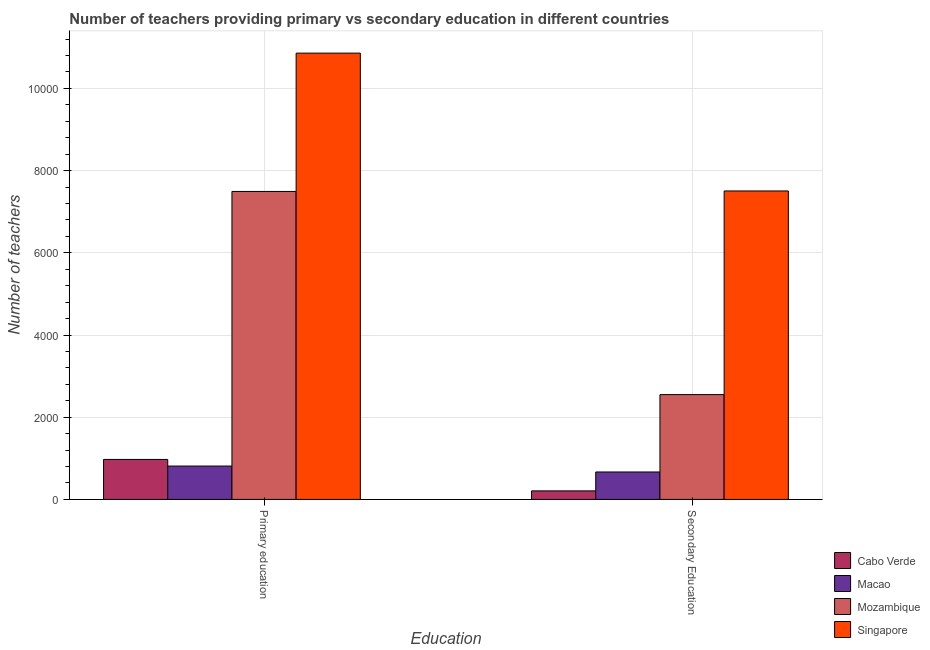How many different coloured bars are there?
Your answer should be compact. 4. Are the number of bars on each tick of the X-axis equal?
Provide a succinct answer. Yes. What is the label of the 2nd group of bars from the left?
Make the answer very short. Secondary Education. What is the number of primary teachers in Mozambique?
Your answer should be compact. 7493. Across all countries, what is the maximum number of secondary teachers?
Your answer should be compact. 7505. Across all countries, what is the minimum number of primary teachers?
Offer a very short reply. 812. In which country was the number of secondary teachers maximum?
Give a very brief answer. Singapore. In which country was the number of secondary teachers minimum?
Provide a short and direct response. Cabo Verde. What is the total number of primary teachers in the graph?
Your answer should be compact. 2.01e+04. What is the difference between the number of primary teachers in Cabo Verde and that in Macao?
Provide a short and direct response. 161. What is the difference between the number of secondary teachers in Cabo Verde and the number of primary teachers in Macao?
Your response must be concise. -604. What is the average number of primary teachers per country?
Your answer should be very brief. 5034. What is the difference between the number of secondary teachers and number of primary teachers in Macao?
Provide a succinct answer. -144. In how many countries, is the number of primary teachers greater than 9200 ?
Provide a succinct answer. 1. What is the ratio of the number of primary teachers in Singapore to that in Cabo Verde?
Provide a succinct answer. 11.16. In how many countries, is the number of primary teachers greater than the average number of primary teachers taken over all countries?
Your answer should be very brief. 2. What does the 2nd bar from the left in Primary education represents?
Your answer should be compact. Macao. What does the 4th bar from the right in Secondary Education represents?
Ensure brevity in your answer.  Cabo Verde. Are all the bars in the graph horizontal?
Provide a short and direct response. No. Does the graph contain any zero values?
Your response must be concise. No. Where does the legend appear in the graph?
Provide a short and direct response. Bottom right. How many legend labels are there?
Make the answer very short. 4. How are the legend labels stacked?
Give a very brief answer. Vertical. What is the title of the graph?
Give a very brief answer. Number of teachers providing primary vs secondary education in different countries. Does "Madagascar" appear as one of the legend labels in the graph?
Offer a very short reply. No. What is the label or title of the X-axis?
Your response must be concise. Education. What is the label or title of the Y-axis?
Keep it short and to the point. Number of teachers. What is the Number of teachers in Cabo Verde in Primary education?
Ensure brevity in your answer.  973. What is the Number of teachers of Macao in Primary education?
Provide a short and direct response. 812. What is the Number of teachers in Mozambique in Primary education?
Offer a very short reply. 7493. What is the Number of teachers of Singapore in Primary education?
Ensure brevity in your answer.  1.09e+04. What is the Number of teachers of Cabo Verde in Secondary Education?
Make the answer very short. 208. What is the Number of teachers of Macao in Secondary Education?
Make the answer very short. 668. What is the Number of teachers of Mozambique in Secondary Education?
Make the answer very short. 2550. What is the Number of teachers of Singapore in Secondary Education?
Ensure brevity in your answer.  7505. Across all Education, what is the maximum Number of teachers of Cabo Verde?
Your answer should be very brief. 973. Across all Education, what is the maximum Number of teachers of Macao?
Keep it short and to the point. 812. Across all Education, what is the maximum Number of teachers in Mozambique?
Offer a terse response. 7493. Across all Education, what is the maximum Number of teachers of Singapore?
Keep it short and to the point. 1.09e+04. Across all Education, what is the minimum Number of teachers in Cabo Verde?
Your response must be concise. 208. Across all Education, what is the minimum Number of teachers in Macao?
Give a very brief answer. 668. Across all Education, what is the minimum Number of teachers in Mozambique?
Offer a terse response. 2550. Across all Education, what is the minimum Number of teachers in Singapore?
Ensure brevity in your answer.  7505. What is the total Number of teachers in Cabo Verde in the graph?
Your answer should be compact. 1181. What is the total Number of teachers in Macao in the graph?
Give a very brief answer. 1480. What is the total Number of teachers of Mozambique in the graph?
Ensure brevity in your answer.  1.00e+04. What is the total Number of teachers in Singapore in the graph?
Make the answer very short. 1.84e+04. What is the difference between the Number of teachers of Cabo Verde in Primary education and that in Secondary Education?
Keep it short and to the point. 765. What is the difference between the Number of teachers of Macao in Primary education and that in Secondary Education?
Ensure brevity in your answer.  144. What is the difference between the Number of teachers of Mozambique in Primary education and that in Secondary Education?
Your response must be concise. 4943. What is the difference between the Number of teachers in Singapore in Primary education and that in Secondary Education?
Your answer should be compact. 3353. What is the difference between the Number of teachers in Cabo Verde in Primary education and the Number of teachers in Macao in Secondary Education?
Provide a succinct answer. 305. What is the difference between the Number of teachers of Cabo Verde in Primary education and the Number of teachers of Mozambique in Secondary Education?
Provide a succinct answer. -1577. What is the difference between the Number of teachers of Cabo Verde in Primary education and the Number of teachers of Singapore in Secondary Education?
Your response must be concise. -6532. What is the difference between the Number of teachers of Macao in Primary education and the Number of teachers of Mozambique in Secondary Education?
Your answer should be compact. -1738. What is the difference between the Number of teachers in Macao in Primary education and the Number of teachers in Singapore in Secondary Education?
Your answer should be very brief. -6693. What is the difference between the Number of teachers of Mozambique in Primary education and the Number of teachers of Singapore in Secondary Education?
Provide a succinct answer. -12. What is the average Number of teachers in Cabo Verde per Education?
Ensure brevity in your answer.  590.5. What is the average Number of teachers in Macao per Education?
Offer a terse response. 740. What is the average Number of teachers in Mozambique per Education?
Your answer should be very brief. 5021.5. What is the average Number of teachers in Singapore per Education?
Your response must be concise. 9181.5. What is the difference between the Number of teachers of Cabo Verde and Number of teachers of Macao in Primary education?
Keep it short and to the point. 161. What is the difference between the Number of teachers in Cabo Verde and Number of teachers in Mozambique in Primary education?
Provide a short and direct response. -6520. What is the difference between the Number of teachers in Cabo Verde and Number of teachers in Singapore in Primary education?
Provide a succinct answer. -9885. What is the difference between the Number of teachers in Macao and Number of teachers in Mozambique in Primary education?
Your answer should be very brief. -6681. What is the difference between the Number of teachers of Macao and Number of teachers of Singapore in Primary education?
Provide a succinct answer. -1.00e+04. What is the difference between the Number of teachers of Mozambique and Number of teachers of Singapore in Primary education?
Offer a very short reply. -3365. What is the difference between the Number of teachers of Cabo Verde and Number of teachers of Macao in Secondary Education?
Your response must be concise. -460. What is the difference between the Number of teachers of Cabo Verde and Number of teachers of Mozambique in Secondary Education?
Your response must be concise. -2342. What is the difference between the Number of teachers of Cabo Verde and Number of teachers of Singapore in Secondary Education?
Keep it short and to the point. -7297. What is the difference between the Number of teachers of Macao and Number of teachers of Mozambique in Secondary Education?
Make the answer very short. -1882. What is the difference between the Number of teachers in Macao and Number of teachers in Singapore in Secondary Education?
Offer a very short reply. -6837. What is the difference between the Number of teachers in Mozambique and Number of teachers in Singapore in Secondary Education?
Give a very brief answer. -4955. What is the ratio of the Number of teachers in Cabo Verde in Primary education to that in Secondary Education?
Ensure brevity in your answer.  4.68. What is the ratio of the Number of teachers in Macao in Primary education to that in Secondary Education?
Provide a succinct answer. 1.22. What is the ratio of the Number of teachers in Mozambique in Primary education to that in Secondary Education?
Make the answer very short. 2.94. What is the ratio of the Number of teachers in Singapore in Primary education to that in Secondary Education?
Ensure brevity in your answer.  1.45. What is the difference between the highest and the second highest Number of teachers of Cabo Verde?
Make the answer very short. 765. What is the difference between the highest and the second highest Number of teachers in Macao?
Provide a short and direct response. 144. What is the difference between the highest and the second highest Number of teachers of Mozambique?
Keep it short and to the point. 4943. What is the difference between the highest and the second highest Number of teachers in Singapore?
Give a very brief answer. 3353. What is the difference between the highest and the lowest Number of teachers in Cabo Verde?
Your answer should be compact. 765. What is the difference between the highest and the lowest Number of teachers in Macao?
Your answer should be compact. 144. What is the difference between the highest and the lowest Number of teachers of Mozambique?
Your response must be concise. 4943. What is the difference between the highest and the lowest Number of teachers of Singapore?
Make the answer very short. 3353. 